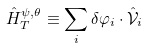<formula> <loc_0><loc_0><loc_500><loc_500>\hat { H } _ { T } ^ { \psi , \theta } \equiv \sum _ { i } \delta \varphi _ { i } \cdot \hat { \mathcal { V } } _ { i }</formula> 